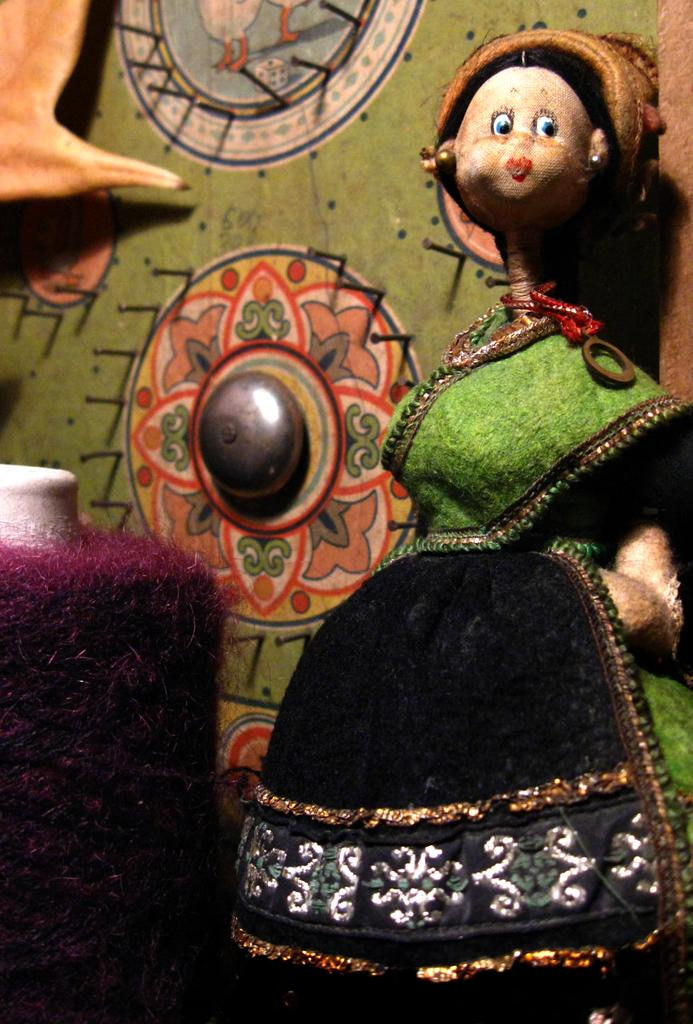Who or what is present on the right side of the image? There is a person on the right side of the image. Can you describe the location of the person in the image? The person is on the right side of the image. What else can be seen in the image besides the person? There is an object on the left side of the image. Can you describe the location of the object in the image? The object is on the left side of the image. What type of brain can be seen in the image? There is no brain present in the image. Is the fireman visible in the image? There is no mention of a fireman in the provided facts, so we cannot determine if one is present in the image. 